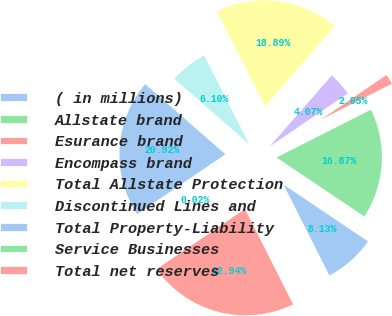Convert chart. <chart><loc_0><loc_0><loc_500><loc_500><pie_chart><fcel>( in millions)<fcel>Allstate brand<fcel>Esurance brand<fcel>Encompass brand<fcel>Total Allstate Protection<fcel>Discontinued Lines and<fcel>Total Property-Liability<fcel>Service Businesses<fcel>Total net reserves<nl><fcel>8.13%<fcel>16.87%<fcel>2.05%<fcel>4.07%<fcel>18.89%<fcel>6.1%<fcel>20.92%<fcel>0.02%<fcel>22.94%<nl></chart> 